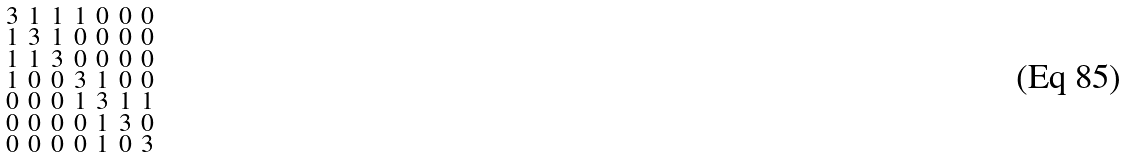<formula> <loc_0><loc_0><loc_500><loc_500>\begin{smallmatrix} 3 & 1 & 1 & 1 & 0 & 0 & 0 \\ 1 & 3 & 1 & 0 & 0 & 0 & 0 \\ 1 & 1 & 3 & 0 & 0 & 0 & 0 \\ 1 & 0 & 0 & 3 & 1 & 0 & 0 \\ 0 & 0 & 0 & 1 & 3 & 1 & 1 \\ 0 & 0 & 0 & 0 & 1 & 3 & 0 \\ 0 & 0 & 0 & 0 & 1 & 0 & 3 \end{smallmatrix}</formula> 